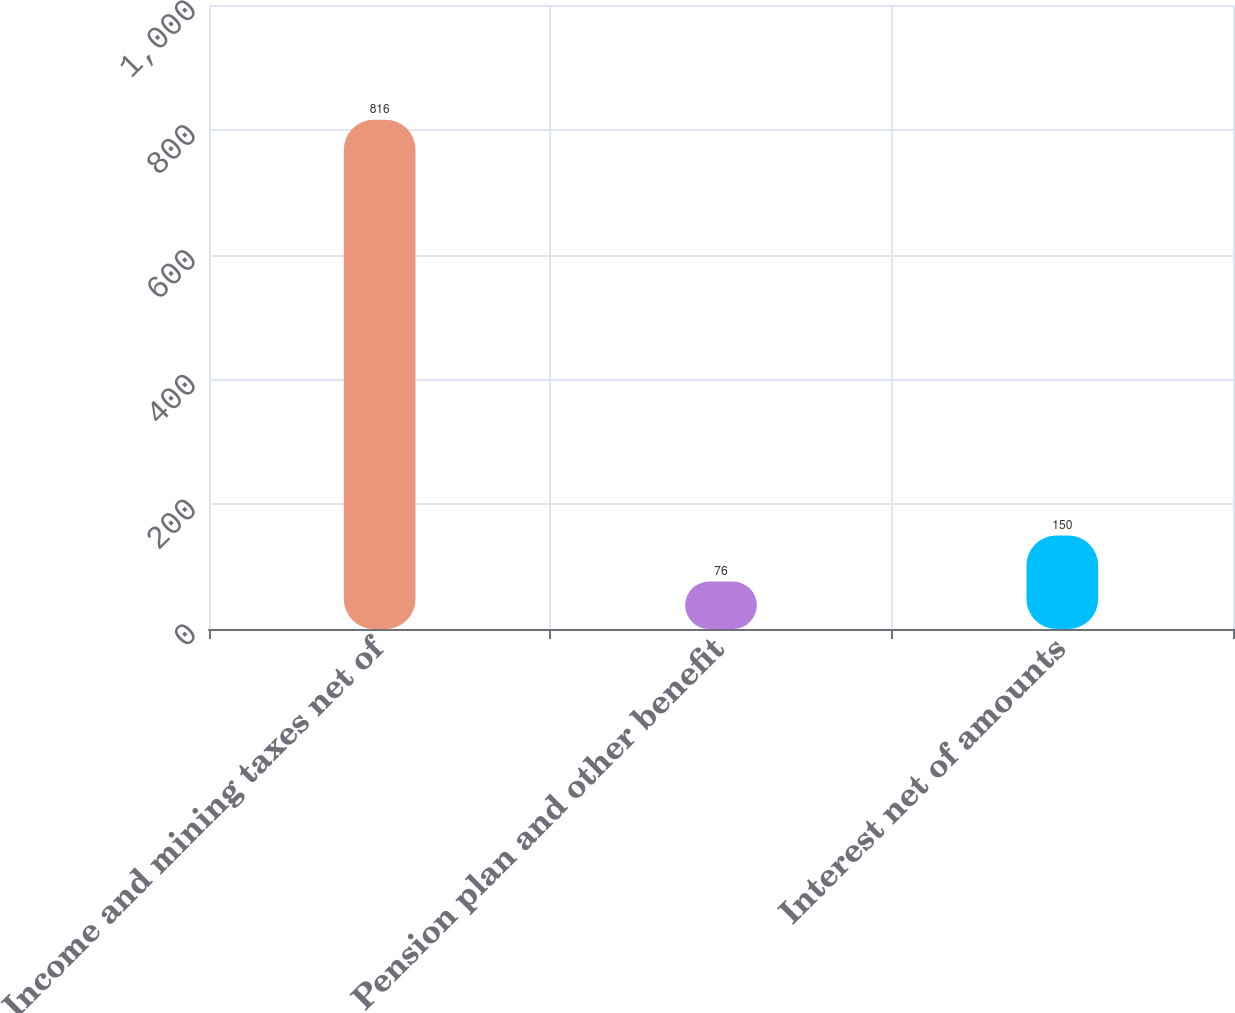<chart> <loc_0><loc_0><loc_500><loc_500><bar_chart><fcel>Income and mining taxes net of<fcel>Pension plan and other benefit<fcel>Interest net of amounts<nl><fcel>816<fcel>76<fcel>150<nl></chart> 